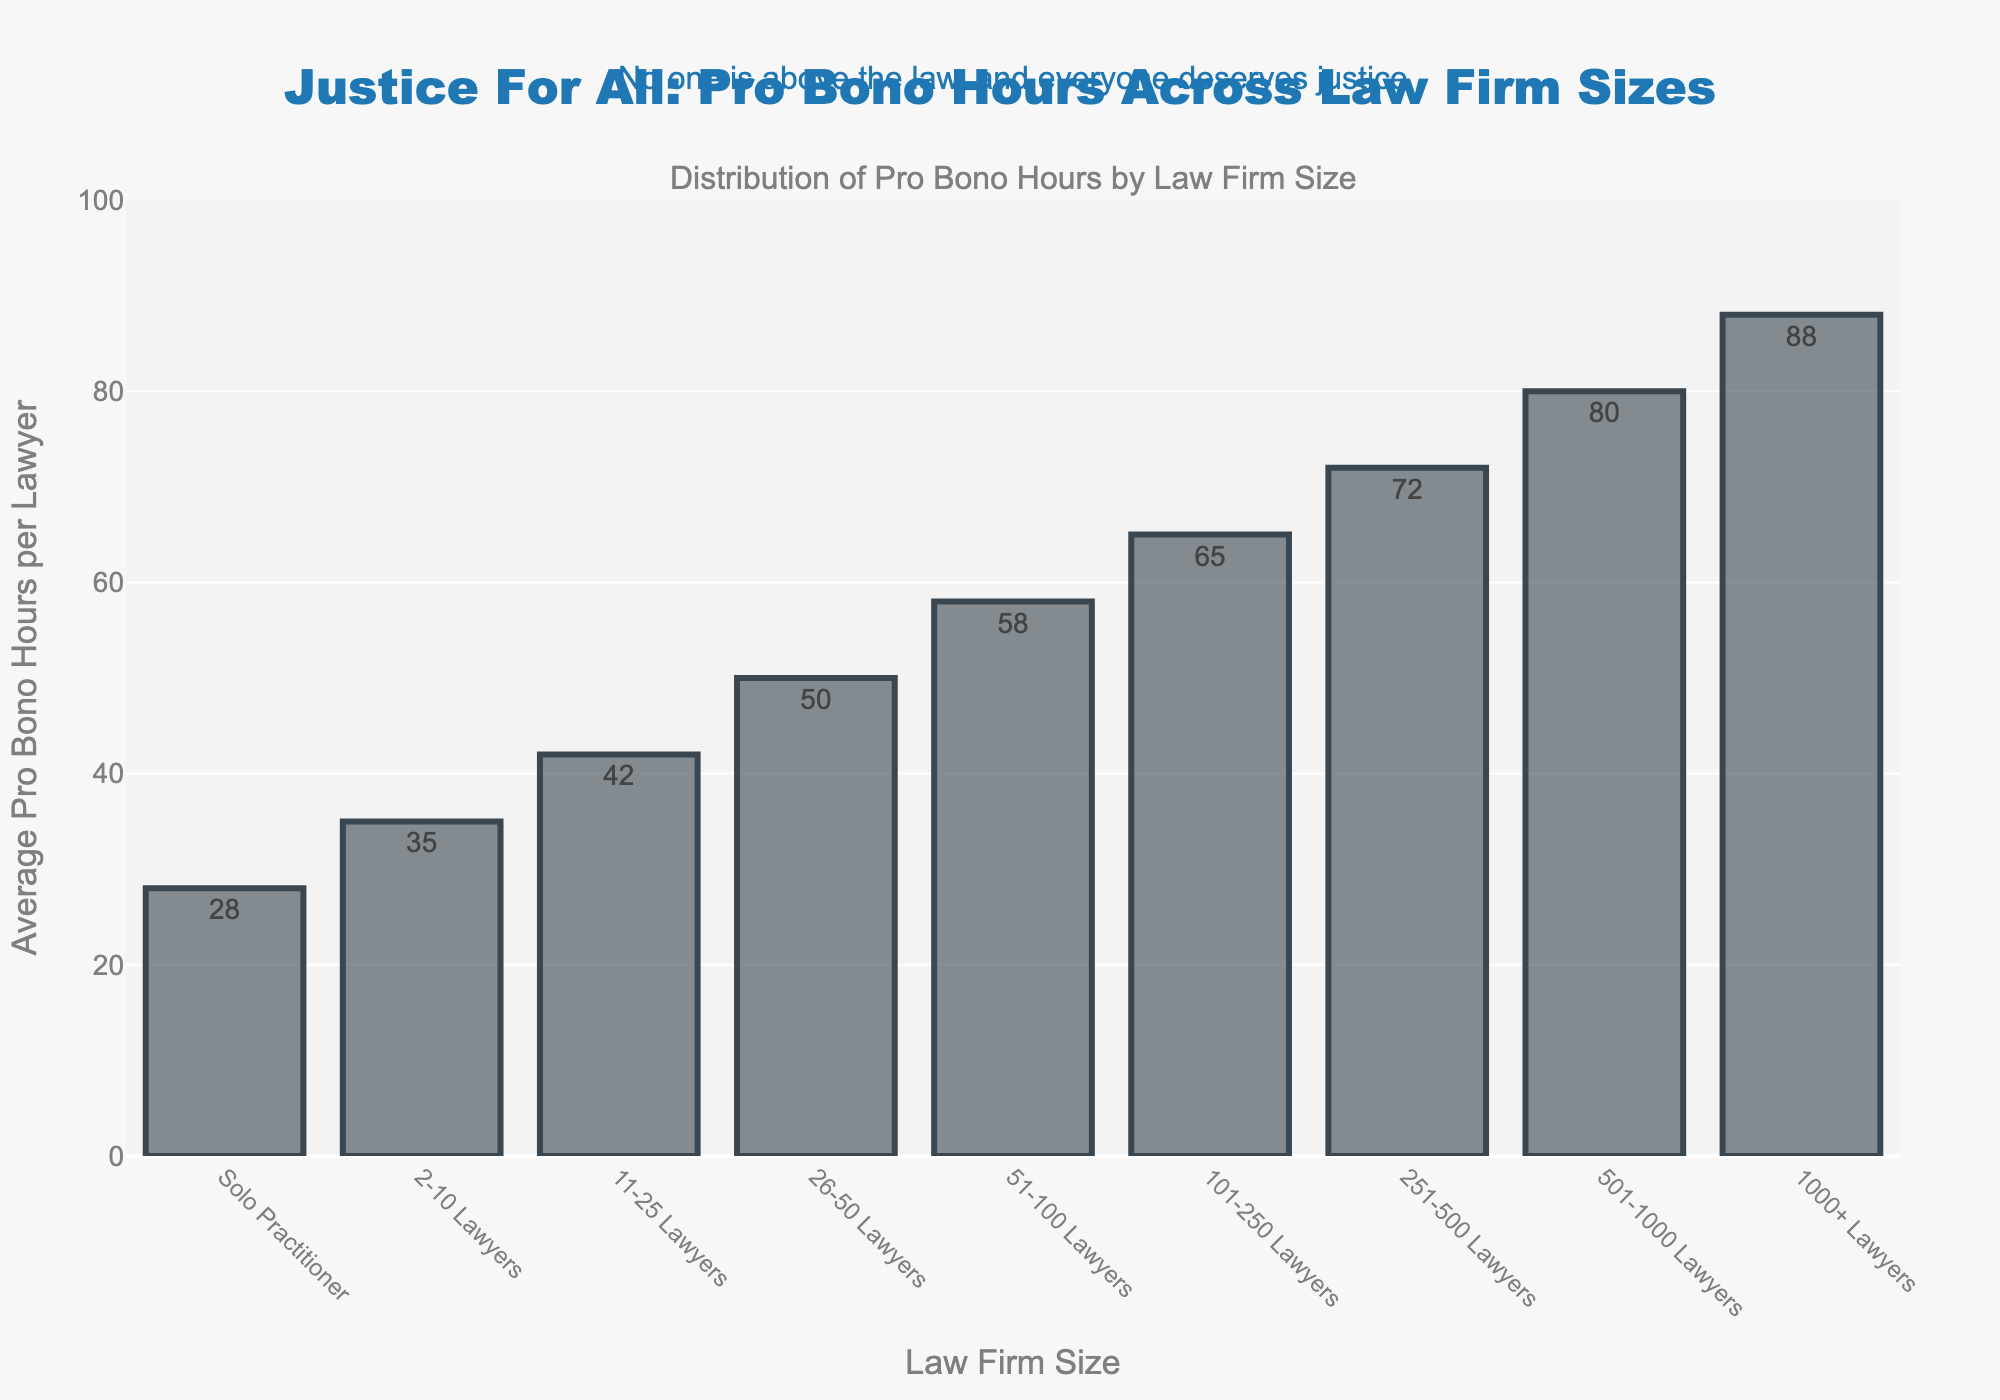Which firm size contributes the highest average pro bono hours per lawyer? The bar chart shows that the firm with "1000+ Lawyers" has the tallest bar, indicating it contributes the highest average pro bono hours per lawyer, which is 88.
Answer: 1000+ Lawyers What is the difference in average pro bono hours between solo practitioners and firms with 1000+ lawyers? Solo Practitioners contribute 28 hours on average, and firms with 1000+ Lawyers contribute 88 hours. The difference is 88 - 28.
Answer: 60 Compare the average pro bono hours of firms with 51-100 lawyers and those with 501-1000 lawyers. Which one is larger and by how much? Firms with 51-100 Lawyers contribute 58 hours per lawyer, while those with 501-1000 Lawyers contribute 80 hours. The difference is 80 - 58.
Answer: 501-1000 by 22 hours How much more average pro bono hours per lawyer does a firm with 251-500 lawyers contribute compared to a firm with 2-10 lawyers? Firms with 2-10 Lawyers contribute 35 hours on average, while those with 251-500 Lawyers contribute 72 hours. The difference is 72 - 35.
Answer: 37 What is the percentage increase in average pro bono hours from firms with 101-250 lawyers to firms with 1000+ lawyers? Firms with 101-250 Lawyers contribute 65 hours, and firms with 1000+ Lawyers contribute 88 hours. The percentage increase is ((88 - 65) / 65) * 100%.
Answer: 35.38% Is there any visual indication that the pro bono hours increase as firm size increases? Yes, the visual trend in the bar chart shows that as the size of the firm increases, the height of the bars (representing average pro bono hours) also increases.
Answer: Yes By how much do average pro bono hours increase from firms with 26-50 lawyers to 51-100 lawyers? Firms with 26-50 Lawyers contribute 50 hours, while those with 51-100 Lawyers contribute 58 hours. The increase is 58 - 50.
Answer: 8 What is the total of average pro bono hours for all firm sizes combined? Summing all the values: 28 + 35 + 42 + 50 + 58 + 65 + 72 + 80 + 88 = 518.
Answer: 518 If you average the average pro bono hours for firms with up to 100 lawyers (from solo practitioners to 51-100 lawyers), what is the result? The sum for these firm sizes is 28 + 35 + 42 + 50 + 58 = 213. There are 5 firm sizes, so the average is 213 / 5.
Answer: 42.6 